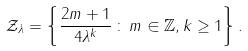<formula> <loc_0><loc_0><loc_500><loc_500>\mathcal { Z } _ { \lambda } = \left \{ \frac { 2 m + 1 } { 4 \lambda ^ { k } } \, \colon \, m \in \mathbb { Z } , k \geq 1 \right \} .</formula> 